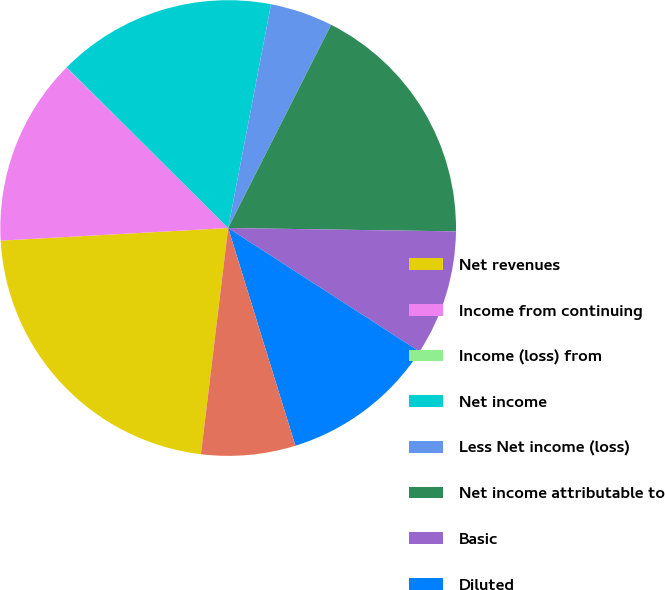<chart> <loc_0><loc_0><loc_500><loc_500><pie_chart><fcel>Net revenues<fcel>Income from continuing<fcel>Income (loss) from<fcel>Net income<fcel>Less Net income (loss)<fcel>Net income attributable to<fcel>Basic<fcel>Diluted<fcel>High<nl><fcel>22.21%<fcel>13.33%<fcel>0.01%<fcel>15.55%<fcel>4.45%<fcel>17.77%<fcel>8.89%<fcel>11.11%<fcel>6.67%<nl></chart> 